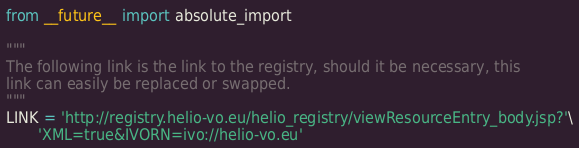Convert code to text. <code><loc_0><loc_0><loc_500><loc_500><_Python_>from __future__ import absolute_import

"""
The following link is the link to the registry, should it be necessary, this
link can easily be replaced or swapped.
"""
LINK = 'http://registry.helio-vo.eu/helio_registry/viewResourceEntry_body.jsp?'\
       'XML=true&IVORN=ivo://helio-vo.eu'
</code> 